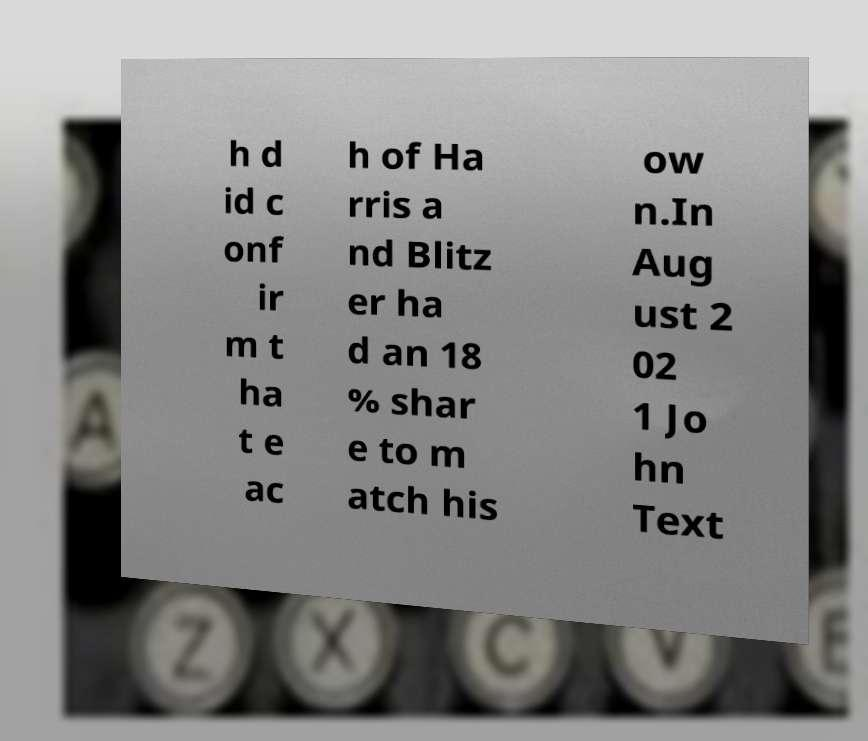I need the written content from this picture converted into text. Can you do that? h d id c onf ir m t ha t e ac h of Ha rris a nd Blitz er ha d an 18 % shar e to m atch his ow n.In Aug ust 2 02 1 Jo hn Text 